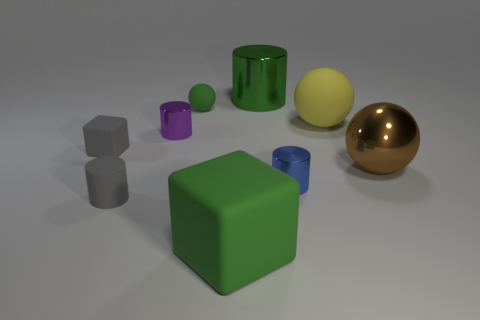Does the blue metallic object have the same shape as the purple shiny object?
Your answer should be compact. Yes. Is the number of small purple cylinders in front of the small gray block greater than the number of tiny gray matte things to the right of the big brown sphere?
Offer a very short reply. No. How many things are either tiny shiny things or tiny green balls?
Your response must be concise. 3. How many other things are there of the same color as the big matte ball?
Make the answer very short. 0. What shape is the yellow rubber thing that is the same size as the brown shiny thing?
Your answer should be compact. Sphere. The tiny cylinder that is in front of the blue metal cylinder is what color?
Make the answer very short. Gray. How many objects are either rubber things behind the tiny blue cylinder or tiny spheres that are to the right of the tiny gray rubber cylinder?
Keep it short and to the point. 3. Do the brown metallic object and the blue metallic thing have the same size?
Ensure brevity in your answer.  No. What number of blocks are either green metallic things or large metal things?
Your answer should be compact. 0. What number of objects are left of the yellow matte ball and in front of the small green rubber ball?
Your answer should be compact. 5. 